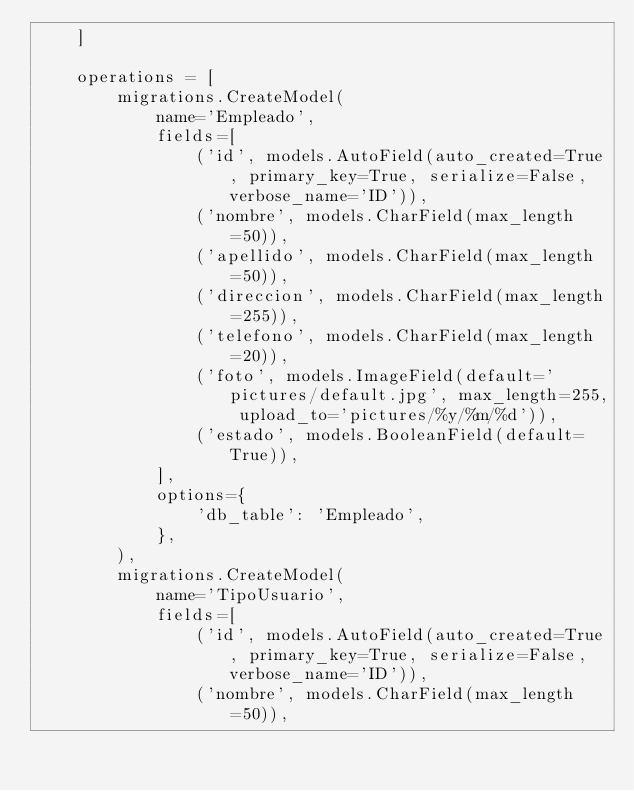Convert code to text. <code><loc_0><loc_0><loc_500><loc_500><_Python_>    ]

    operations = [
        migrations.CreateModel(
            name='Empleado',
            fields=[
                ('id', models.AutoField(auto_created=True, primary_key=True, serialize=False, verbose_name='ID')),
                ('nombre', models.CharField(max_length=50)),
                ('apellido', models.CharField(max_length=50)),
                ('direccion', models.CharField(max_length=255)),
                ('telefono', models.CharField(max_length=20)),
                ('foto', models.ImageField(default='pictures/default.jpg', max_length=255, upload_to='pictures/%y/%m/%d')),
                ('estado', models.BooleanField(default=True)),
            ],
            options={
                'db_table': 'Empleado',
            },
        ),
        migrations.CreateModel(
            name='TipoUsuario',
            fields=[
                ('id', models.AutoField(auto_created=True, primary_key=True, serialize=False, verbose_name='ID')),
                ('nombre', models.CharField(max_length=50)),</code> 